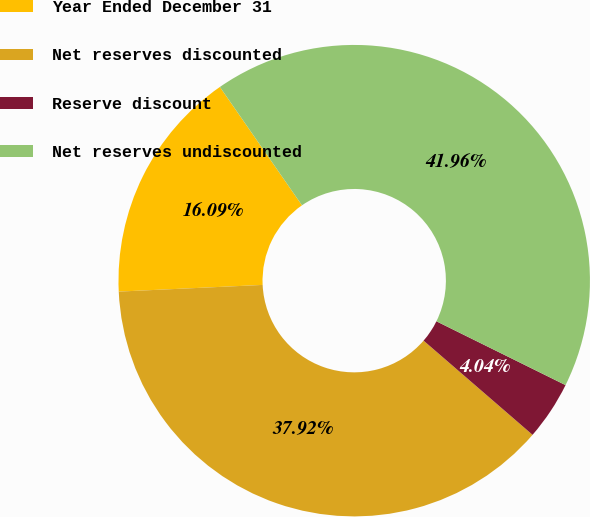<chart> <loc_0><loc_0><loc_500><loc_500><pie_chart><fcel>Year Ended December 31<fcel>Net reserves discounted<fcel>Reserve discount<fcel>Net reserves undiscounted<nl><fcel>16.09%<fcel>37.92%<fcel>4.04%<fcel>41.96%<nl></chart> 